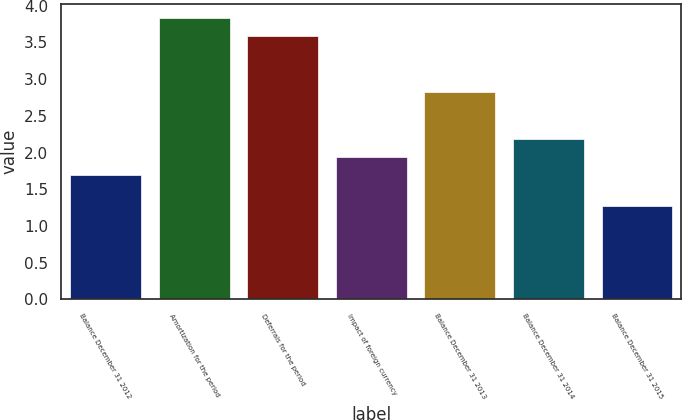Convert chart. <chart><loc_0><loc_0><loc_500><loc_500><bar_chart><fcel>Balance December 31 2012<fcel>Amortization for the period<fcel>Deferrals for the period<fcel>Impact of foreign currency<fcel>Balance December 31 2013<fcel>Balance December 31 2014<fcel>Balance December 31 2015<nl><fcel>1.7<fcel>3.83<fcel>3.59<fcel>1.94<fcel>2.83<fcel>2.18<fcel>1.27<nl></chart> 